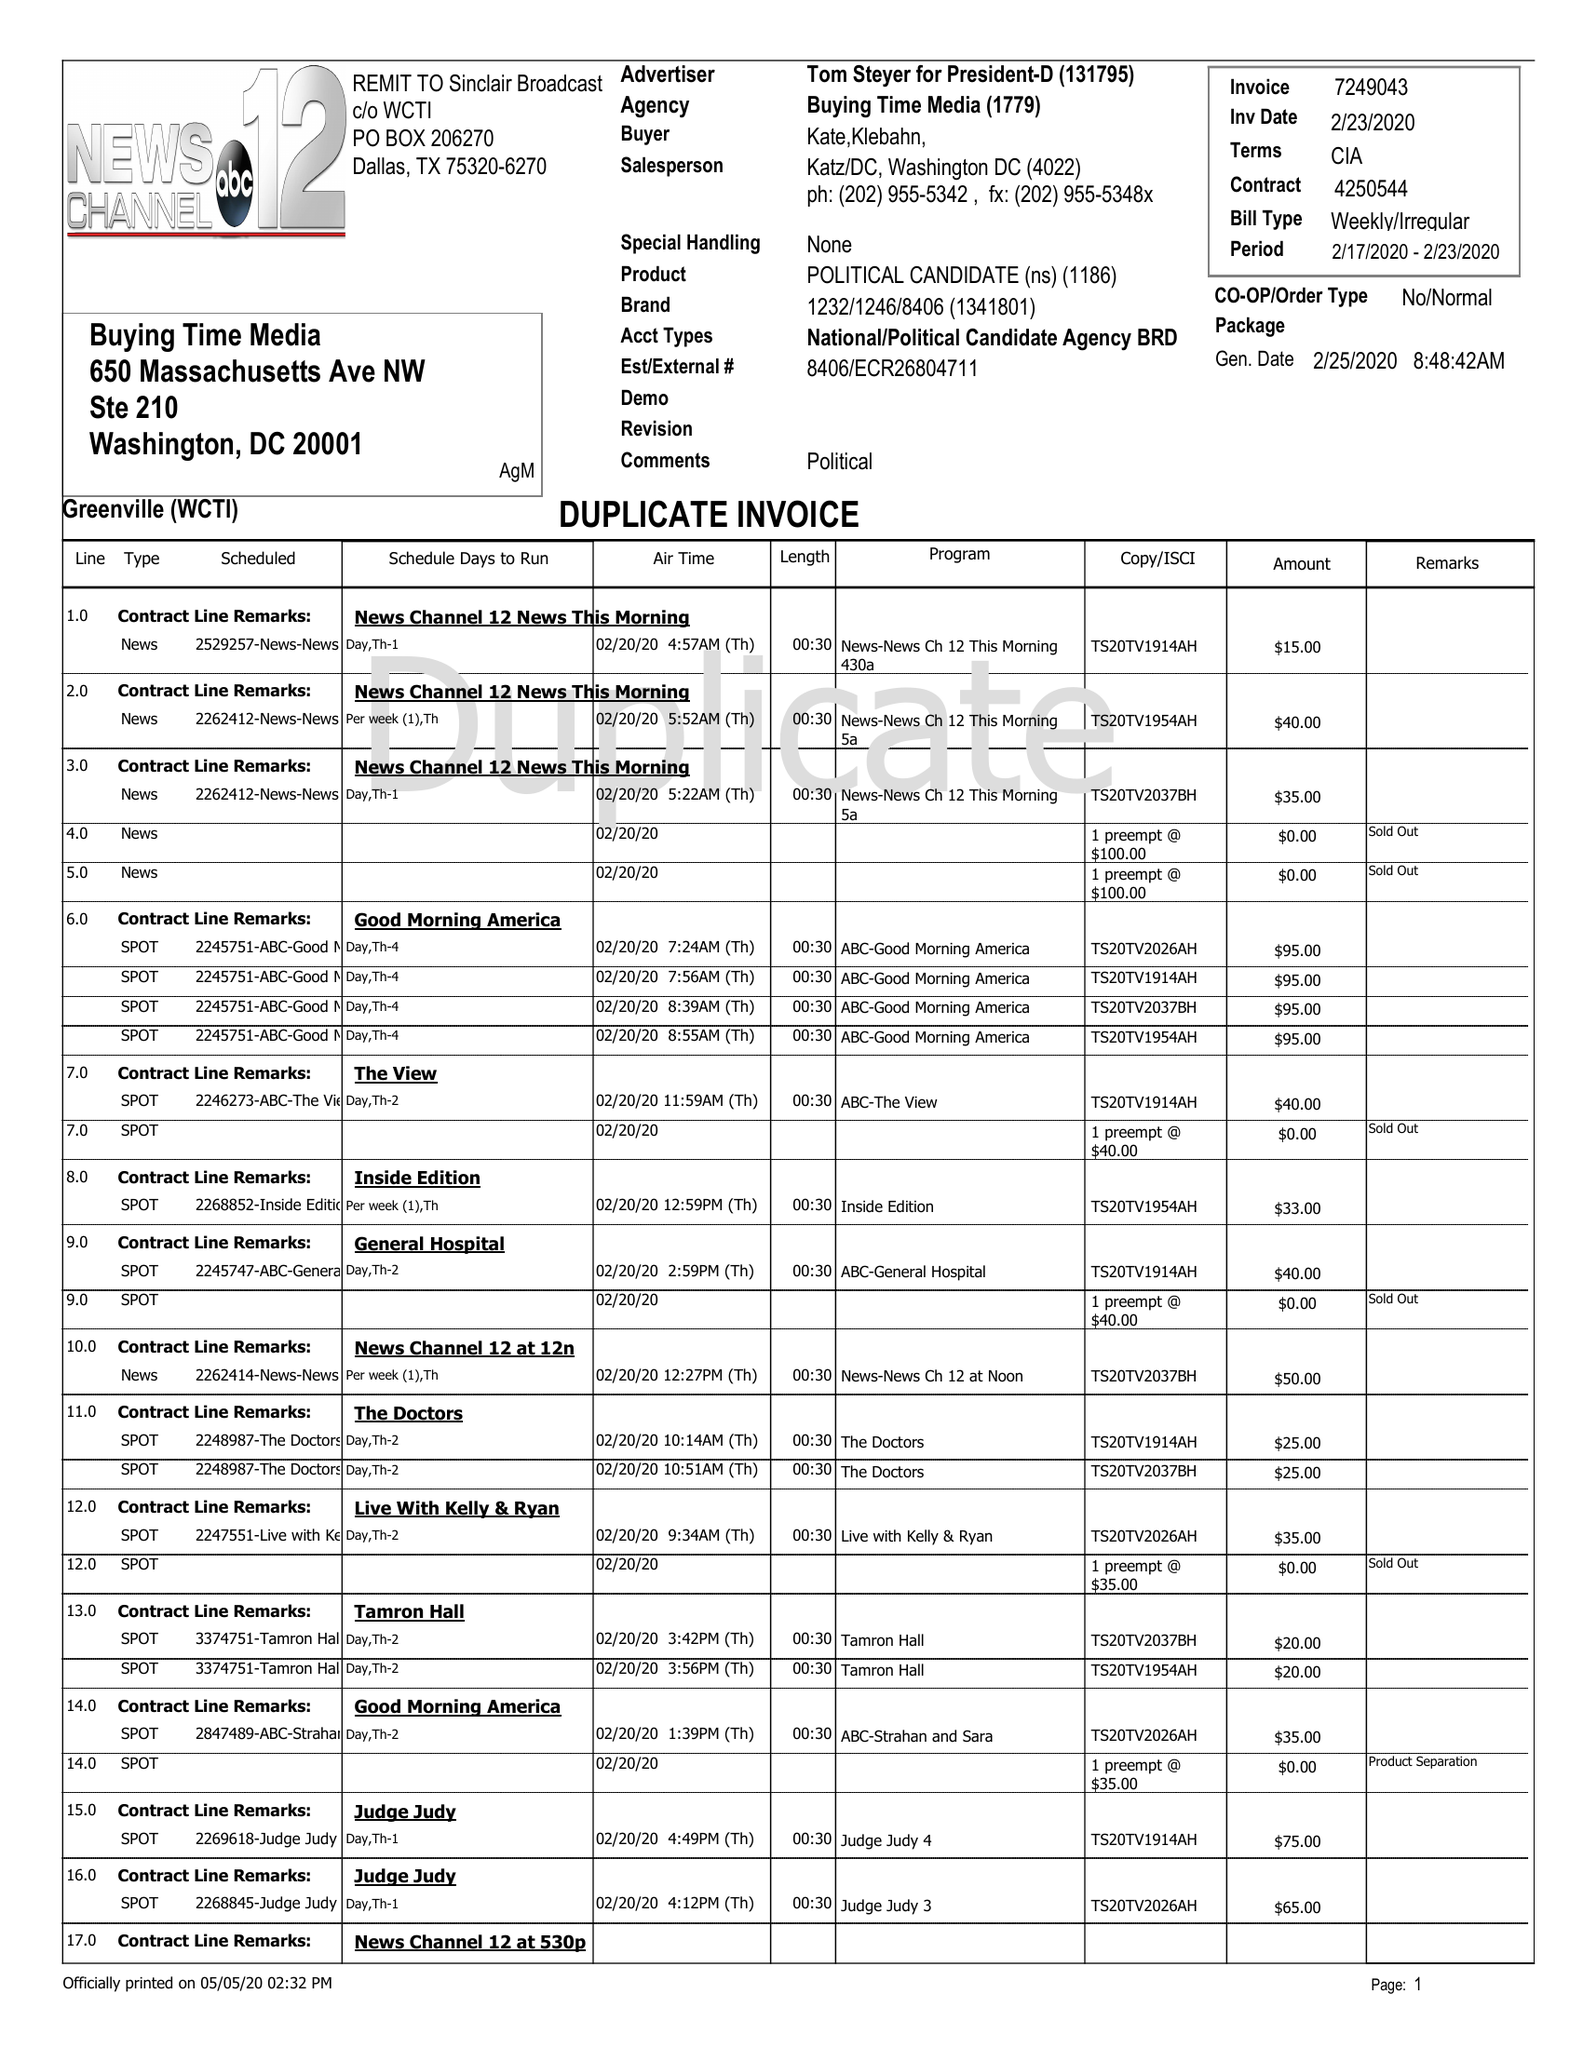What is the value for the flight_to?
Answer the question using a single word or phrase. 02/23/20 